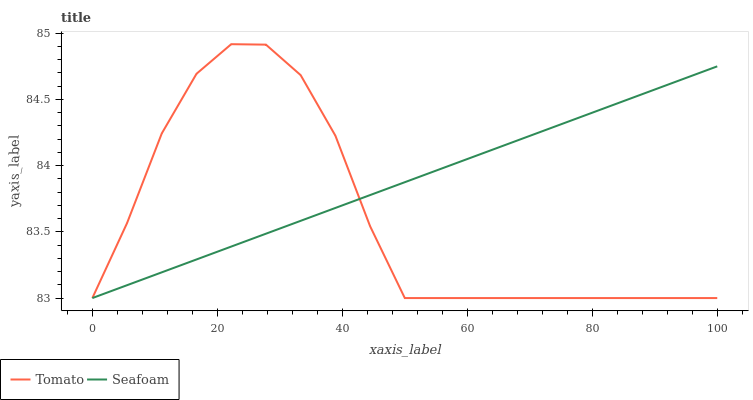Does Tomato have the minimum area under the curve?
Answer yes or no. Yes. Does Seafoam have the maximum area under the curve?
Answer yes or no. Yes. Does Seafoam have the minimum area under the curve?
Answer yes or no. No. Is Seafoam the smoothest?
Answer yes or no. Yes. Is Tomato the roughest?
Answer yes or no. Yes. Is Seafoam the roughest?
Answer yes or no. No. Does Tomato have the lowest value?
Answer yes or no. Yes. Does Tomato have the highest value?
Answer yes or no. Yes. Does Seafoam have the highest value?
Answer yes or no. No. Does Seafoam intersect Tomato?
Answer yes or no. Yes. Is Seafoam less than Tomato?
Answer yes or no. No. Is Seafoam greater than Tomato?
Answer yes or no. No. 